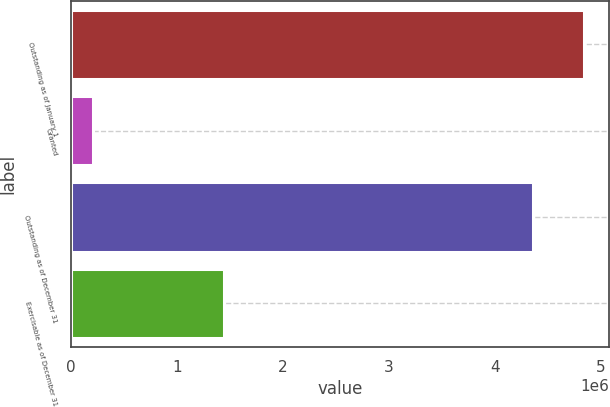<chart> <loc_0><loc_0><loc_500><loc_500><bar_chart><fcel>Outstanding as of January 1<fcel>Granted<fcel>Outstanding as of December 31<fcel>Exercisable as of December 31<nl><fcel>4.83579e+06<fcel>205000<fcel>4.35663e+06<fcel>1.44238e+06<nl></chart> 